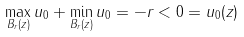Convert formula to latex. <formula><loc_0><loc_0><loc_500><loc_500>\max _ { B _ { r } ( z ) } u _ { 0 } + \min _ { B _ { r } ( z ) } u _ { 0 } = - r < 0 = u _ { 0 } ( z )</formula> 